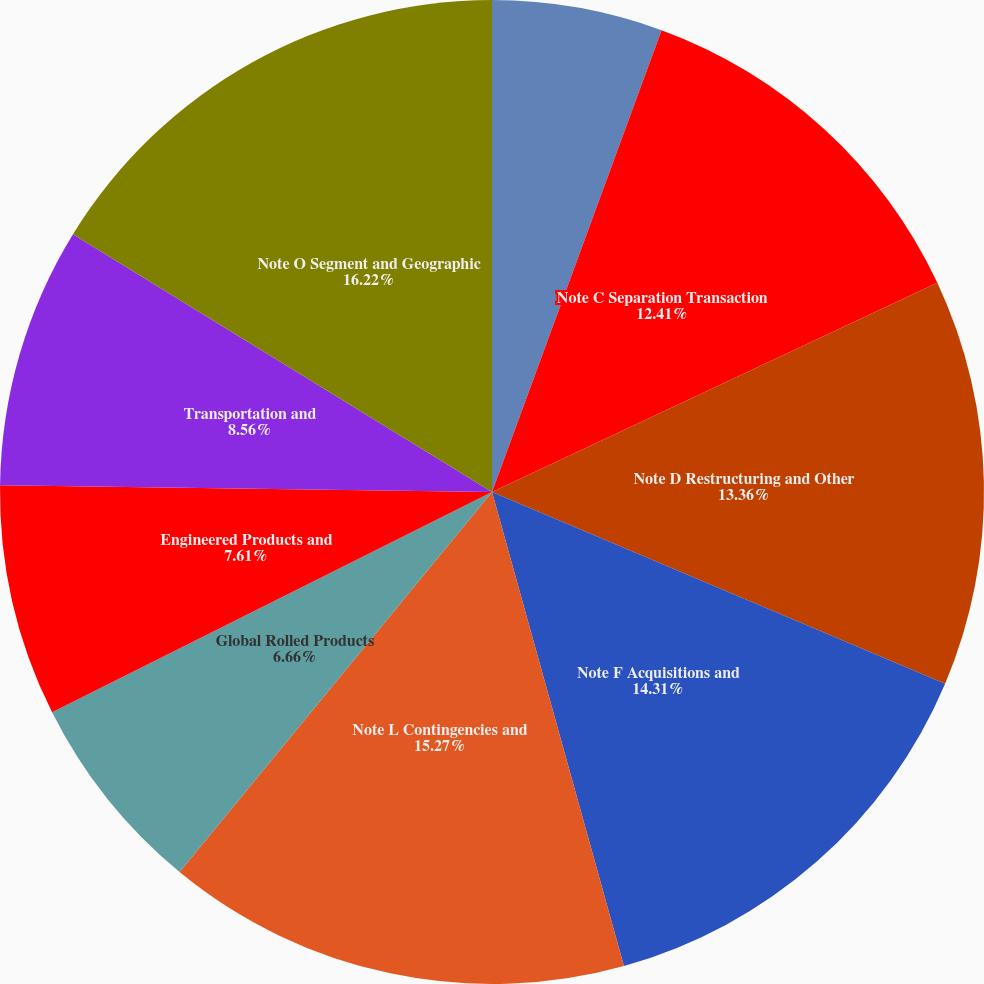<chart> <loc_0><loc_0><loc_500><loc_500><pie_chart><fcel>Overview-Results of Operations<fcel>Note C Separation Transaction<fcel>Note D Restructuring and Other<fcel>Note F Acquisitions and<fcel>Note L Contingencies and<fcel>Global Rolled Products<fcel>Engineered Products and<fcel>Transportation and<fcel>Note O Segment and Geographic<nl><fcel>5.6%<fcel>12.41%<fcel>13.36%<fcel>14.31%<fcel>15.27%<fcel>6.66%<fcel>7.61%<fcel>8.56%<fcel>16.22%<nl></chart> 